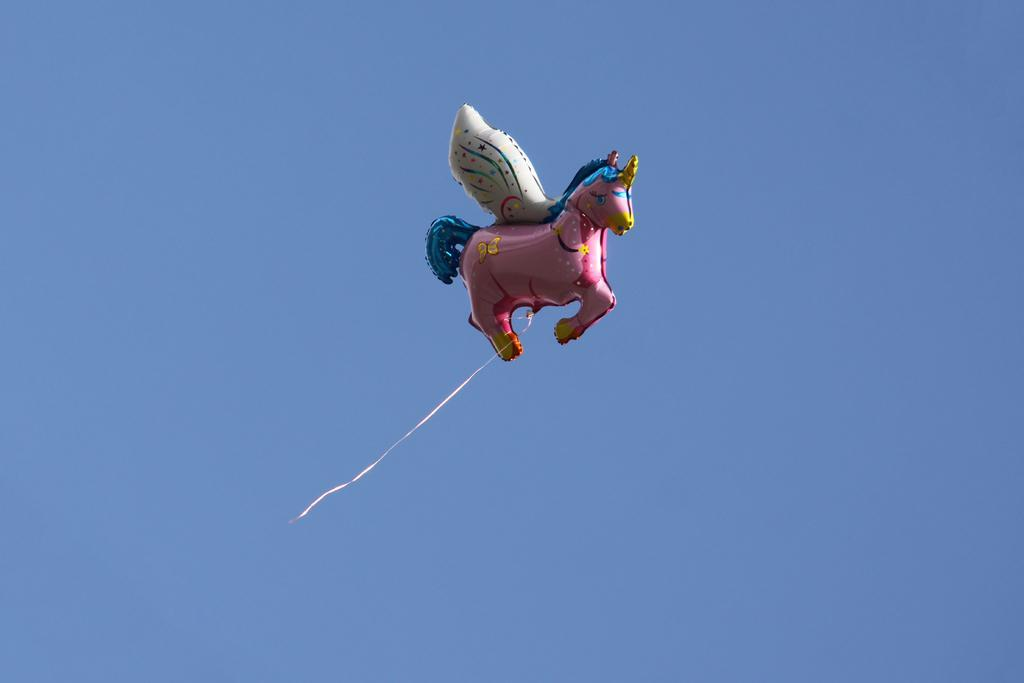What is the main subject of the image? The main subject of the image is a gas balloon. What shape is the gas balloon in the image? The gas balloon is in the shape of a horse. What can be seen in the background of the image? The sky is visible in the background of the image. What flavor of ice cream is being served at the crime scene in the image? There is no ice cream or crime scene present in the image; it features a gas balloon in the shape of a horse with the sky visible in the background. 